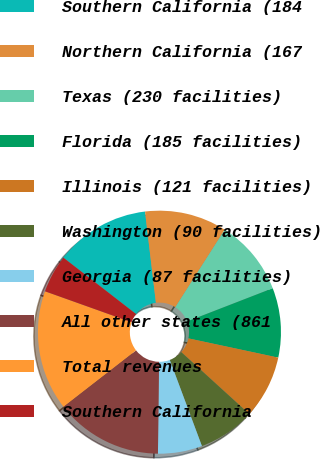Convert chart to OTSL. <chart><loc_0><loc_0><loc_500><loc_500><pie_chart><fcel>Southern California (184<fcel>Northern California (167<fcel>Texas (230 facilities)<fcel>Florida (185 facilities)<fcel>Illinois (121 facilities)<fcel>Washington (90 facilities)<fcel>Georgia (87 facilities)<fcel>All other states (861<fcel>Total revenues<fcel>Southern California<nl><fcel>12.6%<fcel>10.92%<fcel>10.08%<fcel>9.24%<fcel>8.4%<fcel>7.56%<fcel>5.88%<fcel>14.29%<fcel>15.97%<fcel>5.04%<nl></chart> 